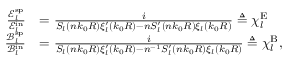Convert formula to latex. <formula><loc_0><loc_0><loc_500><loc_500>\begin{array} { r l } { \frac { \mathcal { E } _ { l } ^ { s p } } { \mathcal { E } _ { l } ^ { i n } } } & { = \frac { i } { S _ { l } ( n k _ { 0 } R ) \xi _ { l } ^ { \prime } ( k _ { 0 } R ) - n S _ { l } ^ { \prime } ( n k _ { 0 } R ) \xi _ { l } ( k _ { 0 } R ) } \triangle q \chi _ { l } ^ { E } } \\ { \frac { \mathcal { B } _ { l } ^ { s p } } { \mathcal { B } _ { l } ^ { i n } } } & { = \frac { i } { S _ { l } ( n k _ { 0 } R ) \xi _ { l } ^ { \prime } ( k _ { 0 } R ) - n ^ { - 1 } S _ { l } ^ { \prime } ( n k _ { 0 } R ) \xi _ { l } ( k _ { 0 } R ) } \triangle q \chi _ { l } ^ { B } , } \end{array}</formula> 